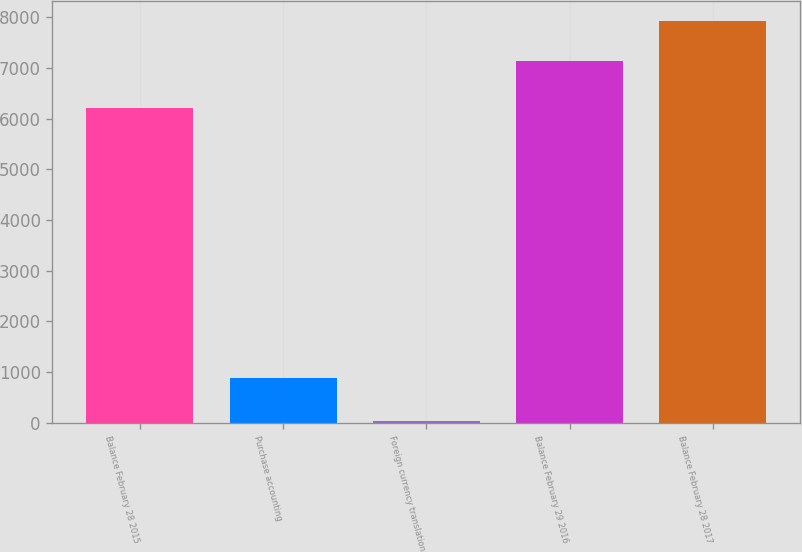<chart> <loc_0><loc_0><loc_500><loc_500><bar_chart><fcel>Balance February 28 2015<fcel>Purchase accounting<fcel>Foreign currency translation<fcel>Balance February 29 2016<fcel>Balance February 28 2017<nl><fcel>6208.2<fcel>884.5<fcel>34.7<fcel>7138.6<fcel>7927.18<nl></chart> 